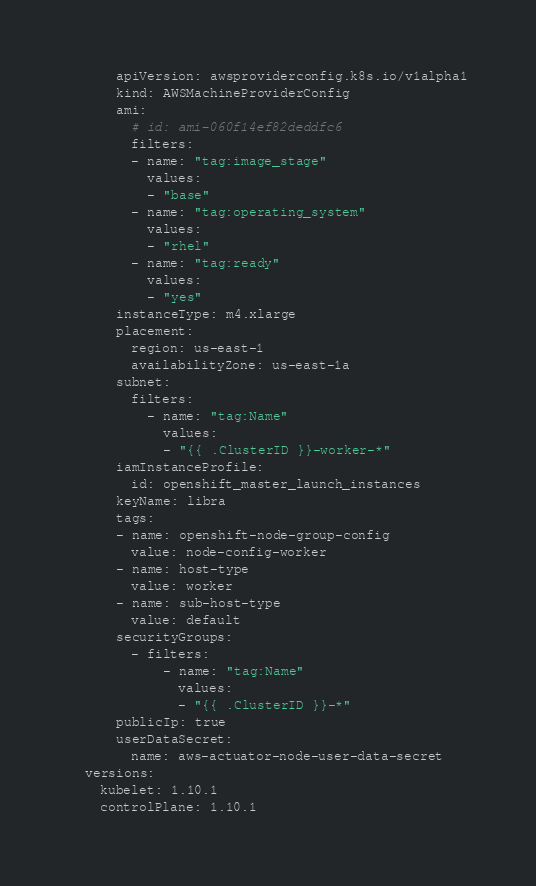<code> <loc_0><loc_0><loc_500><loc_500><_YAML_>      apiVersion: awsproviderconfig.k8s.io/v1alpha1
      kind: AWSMachineProviderConfig
      ami:
        # id: ami-060f14ef82deddfc6
        filters:
        - name: "tag:image_stage"
          values:
          - "base"
        - name: "tag:operating_system"
          values:
          - "rhel"
        - name: "tag:ready"
          values:
          - "yes"
      instanceType: m4.xlarge
      placement:
        region: us-east-1
        availabilityZone: us-east-1a
      subnet:
        filters:
          - name: "tag:Name"
            values:
            - "{{ .ClusterID }}-worker-*"
      iamInstanceProfile:
        id: openshift_master_launch_instances
      keyName: libra
      tags:
      - name: openshift-node-group-config
        value: node-config-worker
      - name: host-type
        value: worker
      - name: sub-host-type
        value: default
      securityGroups:
        - filters:
            - name: "tag:Name"
              values:
              - "{{ .ClusterID }}-*"
      publicIp: true
      userDataSecret:
        name: aws-actuator-node-user-data-secret
  versions:
    kubelet: 1.10.1
    controlPlane: 1.10.1
</code> 